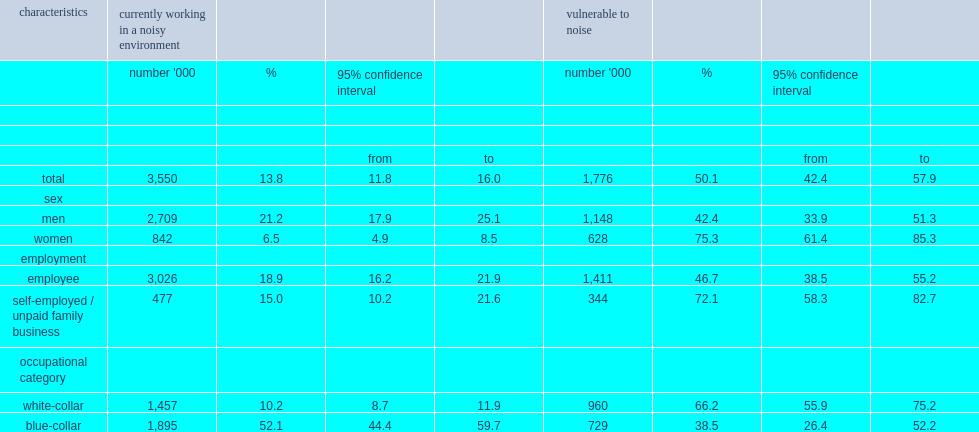How many canadians are currently working in noisy environments over the 2012-to-2015 period? 3550.0. What is the percentage of canadians are currently working in noisy environments over the 2012-to-2015 period? 13.8. What is the percentage of workers who are vulnerable to loud noise among those who are currently working in noisy environments? 50.1. Which kind of people who worked in noisy environments is more likely to be vulnerable, the self-employed or employees? Self-employed / unpaid family business. What is the proportion of employees who worked in noisy environments to be vulnerable? 46.7. What is the proportion of the self-employed who worked in noisy environments to be vulnerable? 72.1. Which kind of occupational category is more likely to work in noisy environments, blue-collar or white-collar? Blue-collar. Which kind of occupational category is less likely to be vulnerable to excessive noise, blue-collar or white-collar? Blue-collar. What is the percentage of people in blue-collar occupations to be vulnerable to excessive noise? 38.5. What is the percentage of people in white-collar occupations to be vulnerable to excessive noise? 66.2. 